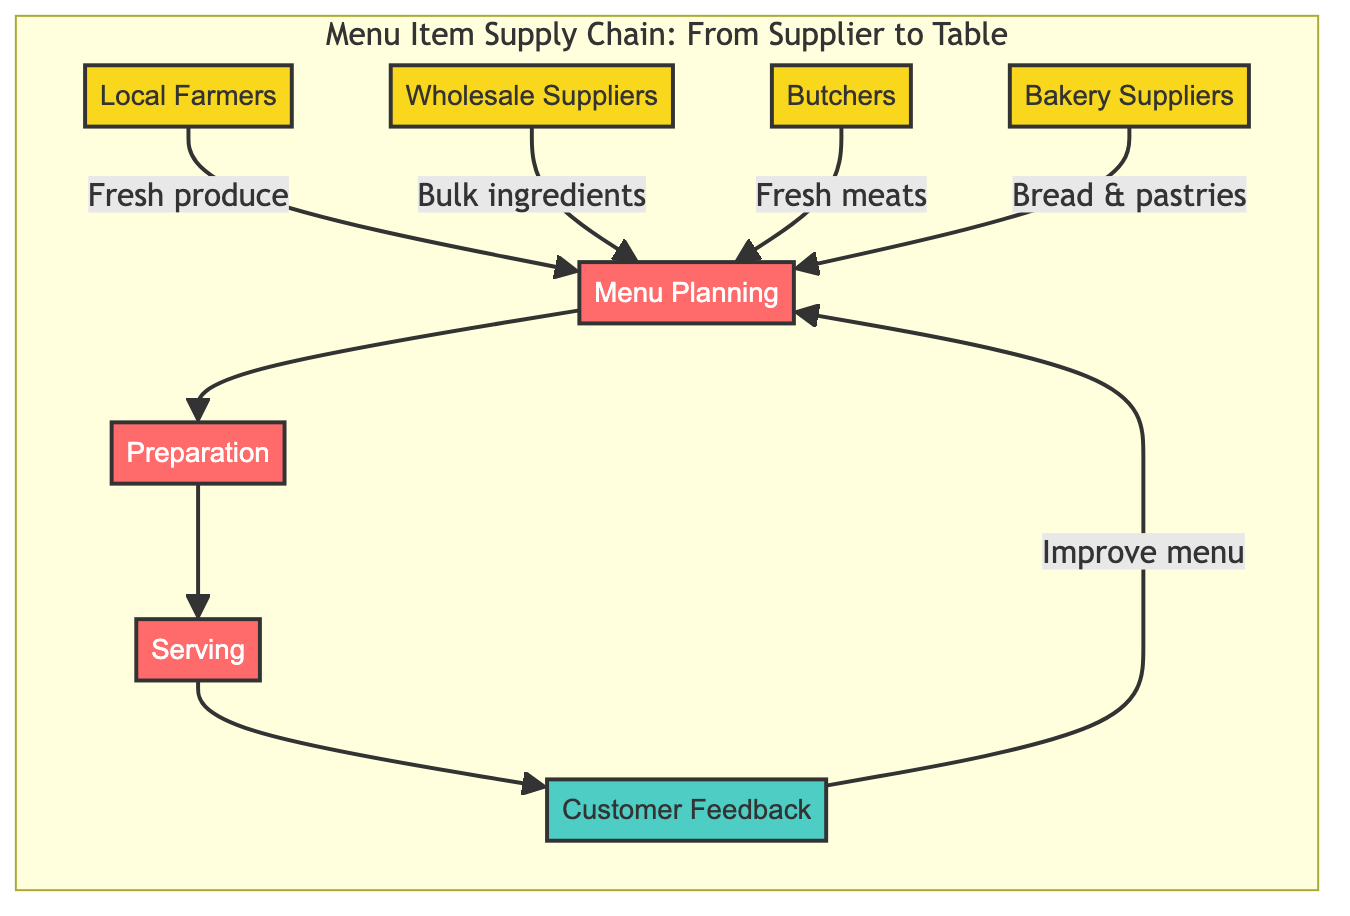What are the suppliers in the diagram? The suppliers identified in the diagram are Local Farmers, Wholesale Suppliers, Butchers, and Bakery Suppliers. They are connected to Menu Planning, indicating they provide the necessary ingredients for the diner.
Answer: Local Farmers, Wholesale Suppliers, Butchers, Bakery Suppliers What is the first process in the flowchart? The first process depicted in the flowchart is Menu Planning. It is the initial step where the diner’s menu is designed based on available ingredients supplied by the suppliers.
Answer: Menu Planning How many processes are there in total? There are four processes in total: Menu Planning, Preparation, Serving, and Customer Feedback. Each of these steps demonstrates how the ingredients transform into a finished meal served to customers.
Answer: Four Which node follows Preparation in the sequence? Following Preparation in the sequence is Serving. This indicates that once the meals are prepared, they are then served to the customers at the diner.
Answer: Serving What influences the Menu Planning process? The Menu Planning process is influenced by the deliveries from Local Farmers, Wholesale Suppliers, Butchers, and Bakery Suppliers. These suppliers provide the fresh ingredients that will inform the menu choices.
Answer: Fresh ingredients How does Customer Feedback affect Menu Planning? Customer Feedback influences Menu Planning as it provides insights on the menu items that customers enjoy, allowing the diner to improve and adapt the menu based on their preferences. This creates a feedback loop whereby the menu can evolve based on customer input.
Answer: Improve menu What type of flow does the diagram illustrate? The diagram illustrates a supply chain flow that moves from suppliers to a series of processes which culminate in serving customers, showing the entire process of delivering food from source to table.
Answer: Supply chain flow Which supplier provides fresh bread? The supplier that provides fresh bread is Bakery Suppliers, which delivers fresh bread and pastries specifically for the diner.
Answer: Bakery Suppliers How are ingredients categorized in the diagram? Ingredients are categorized based on their source, with Local Farmers providing produce, Butchers supplying meats, Wholesale Suppliers delivering bulk items, and Bakery Suppliers supplying bread and pastries.
Answer: By source 